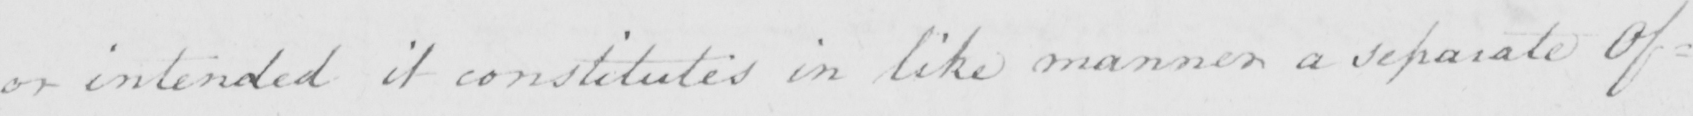What text is written in this handwritten line? or intended it constitutes in like manner a separate of= 